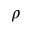Convert formula to latex. <formula><loc_0><loc_0><loc_500><loc_500>\rho</formula> 